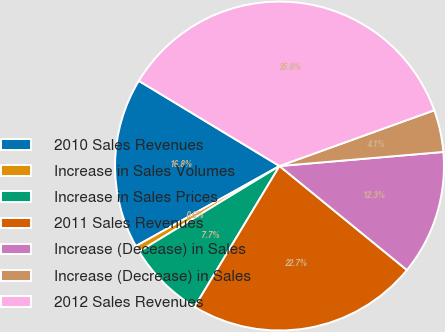<chart> <loc_0><loc_0><loc_500><loc_500><pie_chart><fcel>2010 Sales Revenues<fcel>Increase in Sales Volumes<fcel>Increase in Sales Prices<fcel>2011 Sales Revenues<fcel>Increase (Decease) in Sales<fcel>Increase (Decrease) in Sales<fcel>2012 Sales Revenues<nl><fcel>16.76%<fcel>0.61%<fcel>7.66%<fcel>22.74%<fcel>12.26%<fcel>4.14%<fcel>35.83%<nl></chart> 